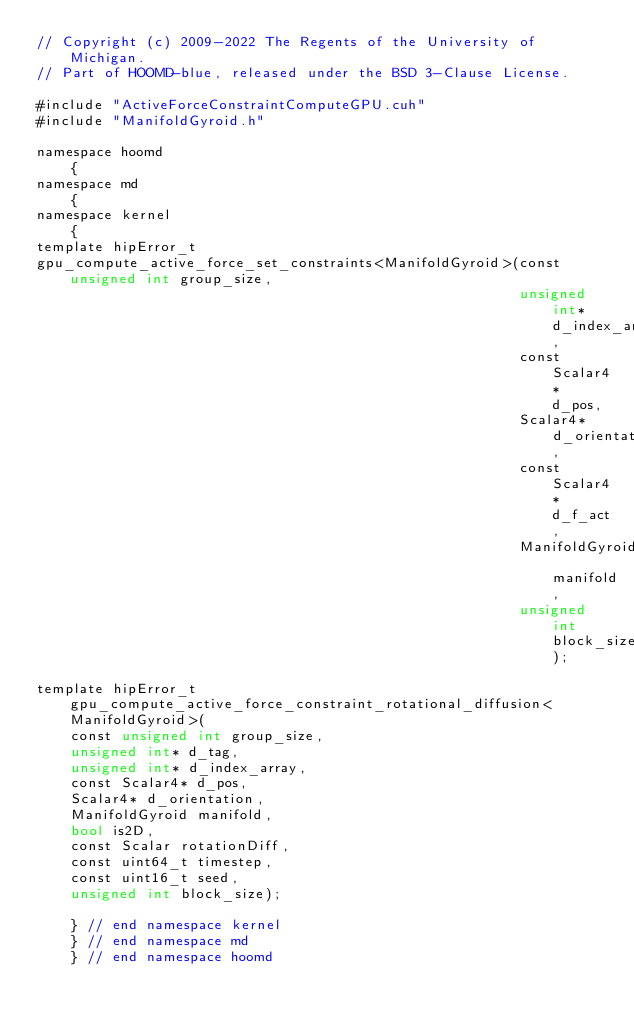Convert code to text. <code><loc_0><loc_0><loc_500><loc_500><_Cuda_>// Copyright (c) 2009-2022 The Regents of the University of Michigan.
// Part of HOOMD-blue, released under the BSD 3-Clause License.

#include "ActiveForceConstraintComputeGPU.cuh"
#include "ManifoldGyroid.h"

namespace hoomd
    {
namespace md
    {
namespace kernel
    {
template hipError_t
gpu_compute_active_force_set_constraints<ManifoldGyroid>(const unsigned int group_size,
                                                         unsigned int* d_index_array,
                                                         const Scalar4* d_pos,
                                                         Scalar4* d_orientation,
                                                         const Scalar4* d_f_act,
                                                         ManifoldGyroid manifold,
                                                         unsigned int block_size);

template hipError_t gpu_compute_active_force_constraint_rotational_diffusion<ManifoldGyroid>(
    const unsigned int group_size,
    unsigned int* d_tag,
    unsigned int* d_index_array,
    const Scalar4* d_pos,
    Scalar4* d_orientation,
    ManifoldGyroid manifold,
    bool is2D,
    const Scalar rotationDiff,
    const uint64_t timestep,
    const uint16_t seed,
    unsigned int block_size);

    } // end namespace kernel
    } // end namespace md
    } // end namespace hoomd
</code> 